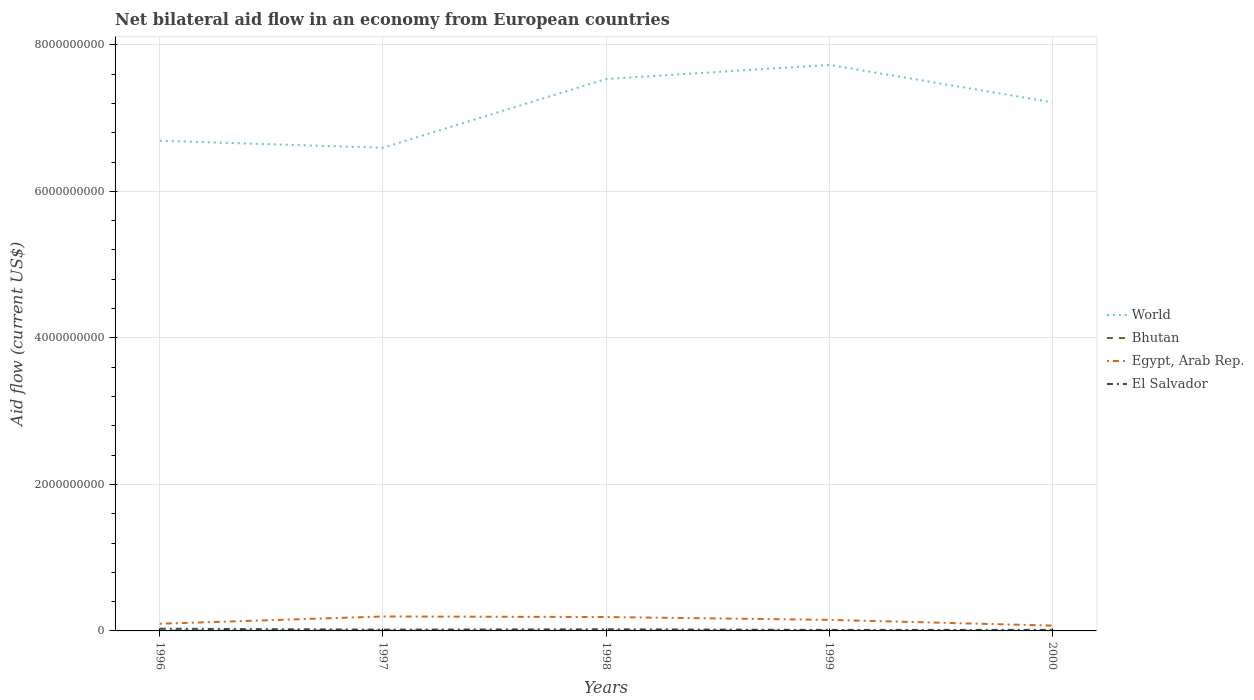What is the total net bilateral aid flow in El Salvador in the graph?
Give a very brief answer. 8.29e+06. What is the difference between the highest and the second highest net bilateral aid flow in Bhutan?
Ensure brevity in your answer.  3.92e+06. Is the net bilateral aid flow in El Salvador strictly greater than the net bilateral aid flow in Egypt, Arab Rep. over the years?
Keep it short and to the point. Yes. How many lines are there?
Your answer should be compact. 4. How many years are there in the graph?
Offer a very short reply. 5. What is the difference between two consecutive major ticks on the Y-axis?
Provide a short and direct response. 2.00e+09. Are the values on the major ticks of Y-axis written in scientific E-notation?
Offer a very short reply. No. Does the graph contain any zero values?
Provide a succinct answer. No. Does the graph contain grids?
Your answer should be compact. Yes. How many legend labels are there?
Provide a short and direct response. 4. How are the legend labels stacked?
Offer a very short reply. Vertical. What is the title of the graph?
Provide a succinct answer. Net bilateral aid flow in an economy from European countries. Does "North America" appear as one of the legend labels in the graph?
Your answer should be very brief. No. What is the label or title of the X-axis?
Offer a very short reply. Years. What is the Aid flow (current US$) in World in 1996?
Provide a short and direct response. 6.69e+09. What is the Aid flow (current US$) in Bhutan in 1996?
Ensure brevity in your answer.  4.82e+06. What is the Aid flow (current US$) of Egypt, Arab Rep. in 1996?
Your answer should be very brief. 9.79e+07. What is the Aid flow (current US$) of El Salvador in 1996?
Make the answer very short. 3.00e+07. What is the Aid flow (current US$) of World in 1997?
Give a very brief answer. 6.60e+09. What is the Aid flow (current US$) in Bhutan in 1997?
Your response must be concise. 3.55e+06. What is the Aid flow (current US$) of Egypt, Arab Rep. in 1997?
Provide a succinct answer. 1.97e+08. What is the Aid flow (current US$) in El Salvador in 1997?
Provide a short and direct response. 1.75e+07. What is the Aid flow (current US$) in World in 1998?
Give a very brief answer. 7.53e+09. What is the Aid flow (current US$) in Bhutan in 1998?
Make the answer very short. 2.79e+06. What is the Aid flow (current US$) of Egypt, Arab Rep. in 1998?
Keep it short and to the point. 1.90e+08. What is the Aid flow (current US$) in El Salvador in 1998?
Offer a very short reply. 2.22e+07. What is the Aid flow (current US$) of World in 1999?
Provide a short and direct response. 7.73e+09. What is the Aid flow (current US$) in Bhutan in 1999?
Your response must be concise. 3.50e+06. What is the Aid flow (current US$) in Egypt, Arab Rep. in 1999?
Make the answer very short. 1.51e+08. What is the Aid flow (current US$) in El Salvador in 1999?
Give a very brief answer. 1.39e+07. What is the Aid flow (current US$) of World in 2000?
Provide a succinct answer. 7.22e+09. What is the Aid flow (current US$) in Egypt, Arab Rep. in 2000?
Keep it short and to the point. 7.25e+07. What is the Aid flow (current US$) in El Salvador in 2000?
Keep it short and to the point. 1.45e+07. Across all years, what is the maximum Aid flow (current US$) in World?
Offer a very short reply. 7.73e+09. Across all years, what is the maximum Aid flow (current US$) in Bhutan?
Offer a very short reply. 4.82e+06. Across all years, what is the maximum Aid flow (current US$) of Egypt, Arab Rep.?
Provide a short and direct response. 1.97e+08. Across all years, what is the maximum Aid flow (current US$) of El Salvador?
Your answer should be very brief. 3.00e+07. Across all years, what is the minimum Aid flow (current US$) of World?
Your answer should be very brief. 6.60e+09. Across all years, what is the minimum Aid flow (current US$) in Bhutan?
Ensure brevity in your answer.  9.00e+05. Across all years, what is the minimum Aid flow (current US$) in Egypt, Arab Rep.?
Your answer should be very brief. 7.25e+07. Across all years, what is the minimum Aid flow (current US$) in El Salvador?
Make the answer very short. 1.39e+07. What is the total Aid flow (current US$) in World in the graph?
Keep it short and to the point. 3.58e+1. What is the total Aid flow (current US$) in Bhutan in the graph?
Offer a terse response. 1.56e+07. What is the total Aid flow (current US$) of Egypt, Arab Rep. in the graph?
Provide a short and direct response. 7.08e+08. What is the total Aid flow (current US$) in El Salvador in the graph?
Your answer should be compact. 9.81e+07. What is the difference between the Aid flow (current US$) of World in 1996 and that in 1997?
Offer a very short reply. 9.51e+07. What is the difference between the Aid flow (current US$) of Bhutan in 1996 and that in 1997?
Provide a short and direct response. 1.27e+06. What is the difference between the Aid flow (current US$) of Egypt, Arab Rep. in 1996 and that in 1997?
Your answer should be compact. -9.91e+07. What is the difference between the Aid flow (current US$) in El Salvador in 1996 and that in 1997?
Keep it short and to the point. 1.25e+07. What is the difference between the Aid flow (current US$) of World in 1996 and that in 1998?
Provide a short and direct response. -8.43e+08. What is the difference between the Aid flow (current US$) in Bhutan in 1996 and that in 1998?
Provide a succinct answer. 2.03e+06. What is the difference between the Aid flow (current US$) in Egypt, Arab Rep. in 1996 and that in 1998?
Provide a short and direct response. -9.19e+07. What is the difference between the Aid flow (current US$) in El Salvador in 1996 and that in 1998?
Ensure brevity in your answer.  7.77e+06. What is the difference between the Aid flow (current US$) of World in 1996 and that in 1999?
Ensure brevity in your answer.  -1.04e+09. What is the difference between the Aid flow (current US$) of Bhutan in 1996 and that in 1999?
Your response must be concise. 1.32e+06. What is the difference between the Aid flow (current US$) in Egypt, Arab Rep. in 1996 and that in 1999?
Make the answer very short. -5.30e+07. What is the difference between the Aid flow (current US$) in El Salvador in 1996 and that in 1999?
Give a very brief answer. 1.61e+07. What is the difference between the Aid flow (current US$) of World in 1996 and that in 2000?
Provide a short and direct response. -5.25e+08. What is the difference between the Aid flow (current US$) of Bhutan in 1996 and that in 2000?
Make the answer very short. 3.92e+06. What is the difference between the Aid flow (current US$) of Egypt, Arab Rep. in 1996 and that in 2000?
Ensure brevity in your answer.  2.54e+07. What is the difference between the Aid flow (current US$) of El Salvador in 1996 and that in 2000?
Make the answer very short. 1.55e+07. What is the difference between the Aid flow (current US$) of World in 1997 and that in 1998?
Your answer should be very brief. -9.38e+08. What is the difference between the Aid flow (current US$) in Bhutan in 1997 and that in 1998?
Your response must be concise. 7.60e+05. What is the difference between the Aid flow (current US$) in Egypt, Arab Rep. in 1997 and that in 1998?
Provide a short and direct response. 7.14e+06. What is the difference between the Aid flow (current US$) in El Salvador in 1997 and that in 1998?
Your answer should be very brief. -4.69e+06. What is the difference between the Aid flow (current US$) in World in 1997 and that in 1999?
Give a very brief answer. -1.13e+09. What is the difference between the Aid flow (current US$) in Egypt, Arab Rep. in 1997 and that in 1999?
Your answer should be compact. 4.61e+07. What is the difference between the Aid flow (current US$) of El Salvador in 1997 and that in 1999?
Provide a succinct answer. 3.60e+06. What is the difference between the Aid flow (current US$) in World in 1997 and that in 2000?
Give a very brief answer. -6.20e+08. What is the difference between the Aid flow (current US$) in Bhutan in 1997 and that in 2000?
Provide a succinct answer. 2.65e+06. What is the difference between the Aid flow (current US$) in Egypt, Arab Rep. in 1997 and that in 2000?
Offer a terse response. 1.24e+08. What is the difference between the Aid flow (current US$) in El Salvador in 1997 and that in 2000?
Keep it short and to the point. 3.03e+06. What is the difference between the Aid flow (current US$) in World in 1998 and that in 1999?
Offer a terse response. -1.93e+08. What is the difference between the Aid flow (current US$) in Bhutan in 1998 and that in 1999?
Provide a succinct answer. -7.10e+05. What is the difference between the Aid flow (current US$) in Egypt, Arab Rep. in 1998 and that in 1999?
Provide a succinct answer. 3.90e+07. What is the difference between the Aid flow (current US$) in El Salvador in 1998 and that in 1999?
Make the answer very short. 8.29e+06. What is the difference between the Aid flow (current US$) of World in 1998 and that in 2000?
Provide a short and direct response. 3.18e+08. What is the difference between the Aid flow (current US$) of Bhutan in 1998 and that in 2000?
Give a very brief answer. 1.89e+06. What is the difference between the Aid flow (current US$) in Egypt, Arab Rep. in 1998 and that in 2000?
Your answer should be compact. 1.17e+08. What is the difference between the Aid flow (current US$) in El Salvador in 1998 and that in 2000?
Give a very brief answer. 7.72e+06. What is the difference between the Aid flow (current US$) of World in 1999 and that in 2000?
Your answer should be compact. 5.11e+08. What is the difference between the Aid flow (current US$) of Bhutan in 1999 and that in 2000?
Your response must be concise. 2.60e+06. What is the difference between the Aid flow (current US$) in Egypt, Arab Rep. in 1999 and that in 2000?
Offer a very short reply. 7.84e+07. What is the difference between the Aid flow (current US$) of El Salvador in 1999 and that in 2000?
Your answer should be very brief. -5.70e+05. What is the difference between the Aid flow (current US$) of World in 1996 and the Aid flow (current US$) of Bhutan in 1997?
Keep it short and to the point. 6.69e+09. What is the difference between the Aid flow (current US$) of World in 1996 and the Aid flow (current US$) of Egypt, Arab Rep. in 1997?
Your response must be concise. 6.49e+09. What is the difference between the Aid flow (current US$) in World in 1996 and the Aid flow (current US$) in El Salvador in 1997?
Provide a short and direct response. 6.67e+09. What is the difference between the Aid flow (current US$) in Bhutan in 1996 and the Aid flow (current US$) in Egypt, Arab Rep. in 1997?
Give a very brief answer. -1.92e+08. What is the difference between the Aid flow (current US$) in Bhutan in 1996 and the Aid flow (current US$) in El Salvador in 1997?
Keep it short and to the point. -1.27e+07. What is the difference between the Aid flow (current US$) of Egypt, Arab Rep. in 1996 and the Aid flow (current US$) of El Salvador in 1997?
Ensure brevity in your answer.  8.04e+07. What is the difference between the Aid flow (current US$) in World in 1996 and the Aid flow (current US$) in Bhutan in 1998?
Make the answer very short. 6.69e+09. What is the difference between the Aid flow (current US$) of World in 1996 and the Aid flow (current US$) of Egypt, Arab Rep. in 1998?
Offer a terse response. 6.50e+09. What is the difference between the Aid flow (current US$) of World in 1996 and the Aid flow (current US$) of El Salvador in 1998?
Give a very brief answer. 6.67e+09. What is the difference between the Aid flow (current US$) of Bhutan in 1996 and the Aid flow (current US$) of Egypt, Arab Rep. in 1998?
Make the answer very short. -1.85e+08. What is the difference between the Aid flow (current US$) of Bhutan in 1996 and the Aid flow (current US$) of El Salvador in 1998?
Offer a very short reply. -1.74e+07. What is the difference between the Aid flow (current US$) of Egypt, Arab Rep. in 1996 and the Aid flow (current US$) of El Salvador in 1998?
Give a very brief answer. 7.57e+07. What is the difference between the Aid flow (current US$) in World in 1996 and the Aid flow (current US$) in Bhutan in 1999?
Your answer should be very brief. 6.69e+09. What is the difference between the Aid flow (current US$) in World in 1996 and the Aid flow (current US$) in Egypt, Arab Rep. in 1999?
Offer a very short reply. 6.54e+09. What is the difference between the Aid flow (current US$) of World in 1996 and the Aid flow (current US$) of El Salvador in 1999?
Provide a succinct answer. 6.68e+09. What is the difference between the Aid flow (current US$) in Bhutan in 1996 and the Aid flow (current US$) in Egypt, Arab Rep. in 1999?
Offer a very short reply. -1.46e+08. What is the difference between the Aid flow (current US$) in Bhutan in 1996 and the Aid flow (current US$) in El Salvador in 1999?
Your response must be concise. -9.10e+06. What is the difference between the Aid flow (current US$) of Egypt, Arab Rep. in 1996 and the Aid flow (current US$) of El Salvador in 1999?
Make the answer very short. 8.40e+07. What is the difference between the Aid flow (current US$) in World in 1996 and the Aid flow (current US$) in Bhutan in 2000?
Give a very brief answer. 6.69e+09. What is the difference between the Aid flow (current US$) in World in 1996 and the Aid flow (current US$) in Egypt, Arab Rep. in 2000?
Ensure brevity in your answer.  6.62e+09. What is the difference between the Aid flow (current US$) in World in 1996 and the Aid flow (current US$) in El Salvador in 2000?
Offer a terse response. 6.68e+09. What is the difference between the Aid flow (current US$) in Bhutan in 1996 and the Aid flow (current US$) in Egypt, Arab Rep. in 2000?
Offer a terse response. -6.77e+07. What is the difference between the Aid flow (current US$) of Bhutan in 1996 and the Aid flow (current US$) of El Salvador in 2000?
Your answer should be compact. -9.67e+06. What is the difference between the Aid flow (current US$) in Egypt, Arab Rep. in 1996 and the Aid flow (current US$) in El Salvador in 2000?
Provide a succinct answer. 8.34e+07. What is the difference between the Aid flow (current US$) in World in 1997 and the Aid flow (current US$) in Bhutan in 1998?
Offer a very short reply. 6.59e+09. What is the difference between the Aid flow (current US$) in World in 1997 and the Aid flow (current US$) in Egypt, Arab Rep. in 1998?
Offer a very short reply. 6.41e+09. What is the difference between the Aid flow (current US$) of World in 1997 and the Aid flow (current US$) of El Salvador in 1998?
Offer a terse response. 6.57e+09. What is the difference between the Aid flow (current US$) of Bhutan in 1997 and the Aid flow (current US$) of Egypt, Arab Rep. in 1998?
Your answer should be very brief. -1.86e+08. What is the difference between the Aid flow (current US$) in Bhutan in 1997 and the Aid flow (current US$) in El Salvador in 1998?
Offer a very short reply. -1.87e+07. What is the difference between the Aid flow (current US$) in Egypt, Arab Rep. in 1997 and the Aid flow (current US$) in El Salvador in 1998?
Provide a succinct answer. 1.75e+08. What is the difference between the Aid flow (current US$) of World in 1997 and the Aid flow (current US$) of Bhutan in 1999?
Offer a terse response. 6.59e+09. What is the difference between the Aid flow (current US$) of World in 1997 and the Aid flow (current US$) of Egypt, Arab Rep. in 1999?
Ensure brevity in your answer.  6.44e+09. What is the difference between the Aid flow (current US$) in World in 1997 and the Aid flow (current US$) in El Salvador in 1999?
Ensure brevity in your answer.  6.58e+09. What is the difference between the Aid flow (current US$) in Bhutan in 1997 and the Aid flow (current US$) in Egypt, Arab Rep. in 1999?
Give a very brief answer. -1.47e+08. What is the difference between the Aid flow (current US$) of Bhutan in 1997 and the Aid flow (current US$) of El Salvador in 1999?
Keep it short and to the point. -1.04e+07. What is the difference between the Aid flow (current US$) of Egypt, Arab Rep. in 1997 and the Aid flow (current US$) of El Salvador in 1999?
Provide a short and direct response. 1.83e+08. What is the difference between the Aid flow (current US$) in World in 1997 and the Aid flow (current US$) in Bhutan in 2000?
Your response must be concise. 6.59e+09. What is the difference between the Aid flow (current US$) of World in 1997 and the Aid flow (current US$) of Egypt, Arab Rep. in 2000?
Give a very brief answer. 6.52e+09. What is the difference between the Aid flow (current US$) in World in 1997 and the Aid flow (current US$) in El Salvador in 2000?
Give a very brief answer. 6.58e+09. What is the difference between the Aid flow (current US$) in Bhutan in 1997 and the Aid flow (current US$) in Egypt, Arab Rep. in 2000?
Give a very brief answer. -6.90e+07. What is the difference between the Aid flow (current US$) of Bhutan in 1997 and the Aid flow (current US$) of El Salvador in 2000?
Your response must be concise. -1.09e+07. What is the difference between the Aid flow (current US$) in Egypt, Arab Rep. in 1997 and the Aid flow (current US$) in El Salvador in 2000?
Your answer should be very brief. 1.82e+08. What is the difference between the Aid flow (current US$) of World in 1998 and the Aid flow (current US$) of Bhutan in 1999?
Give a very brief answer. 7.53e+09. What is the difference between the Aid flow (current US$) of World in 1998 and the Aid flow (current US$) of Egypt, Arab Rep. in 1999?
Ensure brevity in your answer.  7.38e+09. What is the difference between the Aid flow (current US$) of World in 1998 and the Aid flow (current US$) of El Salvador in 1999?
Offer a terse response. 7.52e+09. What is the difference between the Aid flow (current US$) in Bhutan in 1998 and the Aid flow (current US$) in Egypt, Arab Rep. in 1999?
Your answer should be very brief. -1.48e+08. What is the difference between the Aid flow (current US$) of Bhutan in 1998 and the Aid flow (current US$) of El Salvador in 1999?
Your answer should be very brief. -1.11e+07. What is the difference between the Aid flow (current US$) of Egypt, Arab Rep. in 1998 and the Aid flow (current US$) of El Salvador in 1999?
Your answer should be very brief. 1.76e+08. What is the difference between the Aid flow (current US$) of World in 1998 and the Aid flow (current US$) of Bhutan in 2000?
Offer a terse response. 7.53e+09. What is the difference between the Aid flow (current US$) of World in 1998 and the Aid flow (current US$) of Egypt, Arab Rep. in 2000?
Provide a short and direct response. 7.46e+09. What is the difference between the Aid flow (current US$) in World in 1998 and the Aid flow (current US$) in El Salvador in 2000?
Offer a terse response. 7.52e+09. What is the difference between the Aid flow (current US$) in Bhutan in 1998 and the Aid flow (current US$) in Egypt, Arab Rep. in 2000?
Provide a succinct answer. -6.97e+07. What is the difference between the Aid flow (current US$) in Bhutan in 1998 and the Aid flow (current US$) in El Salvador in 2000?
Your response must be concise. -1.17e+07. What is the difference between the Aid flow (current US$) of Egypt, Arab Rep. in 1998 and the Aid flow (current US$) of El Salvador in 2000?
Provide a short and direct response. 1.75e+08. What is the difference between the Aid flow (current US$) of World in 1999 and the Aid flow (current US$) of Bhutan in 2000?
Your response must be concise. 7.73e+09. What is the difference between the Aid flow (current US$) of World in 1999 and the Aid flow (current US$) of Egypt, Arab Rep. in 2000?
Keep it short and to the point. 7.65e+09. What is the difference between the Aid flow (current US$) in World in 1999 and the Aid flow (current US$) in El Salvador in 2000?
Your response must be concise. 7.71e+09. What is the difference between the Aid flow (current US$) in Bhutan in 1999 and the Aid flow (current US$) in Egypt, Arab Rep. in 2000?
Offer a very short reply. -6.90e+07. What is the difference between the Aid flow (current US$) of Bhutan in 1999 and the Aid flow (current US$) of El Salvador in 2000?
Keep it short and to the point. -1.10e+07. What is the difference between the Aid flow (current US$) of Egypt, Arab Rep. in 1999 and the Aid flow (current US$) of El Salvador in 2000?
Provide a short and direct response. 1.36e+08. What is the average Aid flow (current US$) of World per year?
Your response must be concise. 7.15e+09. What is the average Aid flow (current US$) of Bhutan per year?
Give a very brief answer. 3.11e+06. What is the average Aid flow (current US$) of Egypt, Arab Rep. per year?
Give a very brief answer. 1.42e+08. What is the average Aid flow (current US$) in El Salvador per year?
Provide a succinct answer. 1.96e+07. In the year 1996, what is the difference between the Aid flow (current US$) of World and Aid flow (current US$) of Bhutan?
Your answer should be very brief. 6.69e+09. In the year 1996, what is the difference between the Aid flow (current US$) in World and Aid flow (current US$) in Egypt, Arab Rep.?
Provide a short and direct response. 6.59e+09. In the year 1996, what is the difference between the Aid flow (current US$) in World and Aid flow (current US$) in El Salvador?
Make the answer very short. 6.66e+09. In the year 1996, what is the difference between the Aid flow (current US$) of Bhutan and Aid flow (current US$) of Egypt, Arab Rep.?
Your answer should be compact. -9.31e+07. In the year 1996, what is the difference between the Aid flow (current US$) in Bhutan and Aid flow (current US$) in El Salvador?
Your answer should be very brief. -2.52e+07. In the year 1996, what is the difference between the Aid flow (current US$) in Egypt, Arab Rep. and Aid flow (current US$) in El Salvador?
Your answer should be compact. 6.79e+07. In the year 1997, what is the difference between the Aid flow (current US$) in World and Aid flow (current US$) in Bhutan?
Your answer should be very brief. 6.59e+09. In the year 1997, what is the difference between the Aid flow (current US$) in World and Aid flow (current US$) in Egypt, Arab Rep.?
Provide a short and direct response. 6.40e+09. In the year 1997, what is the difference between the Aid flow (current US$) in World and Aid flow (current US$) in El Salvador?
Offer a very short reply. 6.58e+09. In the year 1997, what is the difference between the Aid flow (current US$) of Bhutan and Aid flow (current US$) of Egypt, Arab Rep.?
Provide a short and direct response. -1.93e+08. In the year 1997, what is the difference between the Aid flow (current US$) of Bhutan and Aid flow (current US$) of El Salvador?
Provide a succinct answer. -1.40e+07. In the year 1997, what is the difference between the Aid flow (current US$) in Egypt, Arab Rep. and Aid flow (current US$) in El Salvador?
Give a very brief answer. 1.79e+08. In the year 1998, what is the difference between the Aid flow (current US$) in World and Aid flow (current US$) in Bhutan?
Provide a succinct answer. 7.53e+09. In the year 1998, what is the difference between the Aid flow (current US$) in World and Aid flow (current US$) in Egypt, Arab Rep.?
Your answer should be compact. 7.34e+09. In the year 1998, what is the difference between the Aid flow (current US$) of World and Aid flow (current US$) of El Salvador?
Provide a short and direct response. 7.51e+09. In the year 1998, what is the difference between the Aid flow (current US$) of Bhutan and Aid flow (current US$) of Egypt, Arab Rep.?
Your response must be concise. -1.87e+08. In the year 1998, what is the difference between the Aid flow (current US$) of Bhutan and Aid flow (current US$) of El Salvador?
Ensure brevity in your answer.  -1.94e+07. In the year 1998, what is the difference between the Aid flow (current US$) of Egypt, Arab Rep. and Aid flow (current US$) of El Salvador?
Ensure brevity in your answer.  1.68e+08. In the year 1999, what is the difference between the Aid flow (current US$) in World and Aid flow (current US$) in Bhutan?
Provide a succinct answer. 7.72e+09. In the year 1999, what is the difference between the Aid flow (current US$) in World and Aid flow (current US$) in Egypt, Arab Rep.?
Provide a short and direct response. 7.58e+09. In the year 1999, what is the difference between the Aid flow (current US$) of World and Aid flow (current US$) of El Salvador?
Make the answer very short. 7.71e+09. In the year 1999, what is the difference between the Aid flow (current US$) of Bhutan and Aid flow (current US$) of Egypt, Arab Rep.?
Your response must be concise. -1.47e+08. In the year 1999, what is the difference between the Aid flow (current US$) of Bhutan and Aid flow (current US$) of El Salvador?
Your response must be concise. -1.04e+07. In the year 1999, what is the difference between the Aid flow (current US$) in Egypt, Arab Rep. and Aid flow (current US$) in El Salvador?
Your answer should be very brief. 1.37e+08. In the year 2000, what is the difference between the Aid flow (current US$) in World and Aid flow (current US$) in Bhutan?
Your response must be concise. 7.21e+09. In the year 2000, what is the difference between the Aid flow (current US$) in World and Aid flow (current US$) in Egypt, Arab Rep.?
Your response must be concise. 7.14e+09. In the year 2000, what is the difference between the Aid flow (current US$) of World and Aid flow (current US$) of El Salvador?
Provide a succinct answer. 7.20e+09. In the year 2000, what is the difference between the Aid flow (current US$) in Bhutan and Aid flow (current US$) in Egypt, Arab Rep.?
Make the answer very short. -7.16e+07. In the year 2000, what is the difference between the Aid flow (current US$) of Bhutan and Aid flow (current US$) of El Salvador?
Your answer should be very brief. -1.36e+07. In the year 2000, what is the difference between the Aid flow (current US$) of Egypt, Arab Rep. and Aid flow (current US$) of El Salvador?
Ensure brevity in your answer.  5.80e+07. What is the ratio of the Aid flow (current US$) of World in 1996 to that in 1997?
Your response must be concise. 1.01. What is the ratio of the Aid flow (current US$) of Bhutan in 1996 to that in 1997?
Your answer should be compact. 1.36. What is the ratio of the Aid flow (current US$) of Egypt, Arab Rep. in 1996 to that in 1997?
Provide a short and direct response. 0.5. What is the ratio of the Aid flow (current US$) in El Salvador in 1996 to that in 1997?
Your response must be concise. 1.71. What is the ratio of the Aid flow (current US$) of World in 1996 to that in 1998?
Your answer should be compact. 0.89. What is the ratio of the Aid flow (current US$) in Bhutan in 1996 to that in 1998?
Offer a terse response. 1.73. What is the ratio of the Aid flow (current US$) in Egypt, Arab Rep. in 1996 to that in 1998?
Provide a succinct answer. 0.52. What is the ratio of the Aid flow (current US$) in El Salvador in 1996 to that in 1998?
Your answer should be very brief. 1.35. What is the ratio of the Aid flow (current US$) of World in 1996 to that in 1999?
Your answer should be compact. 0.87. What is the ratio of the Aid flow (current US$) of Bhutan in 1996 to that in 1999?
Your answer should be very brief. 1.38. What is the ratio of the Aid flow (current US$) of Egypt, Arab Rep. in 1996 to that in 1999?
Provide a succinct answer. 0.65. What is the ratio of the Aid flow (current US$) in El Salvador in 1996 to that in 1999?
Keep it short and to the point. 2.15. What is the ratio of the Aid flow (current US$) in World in 1996 to that in 2000?
Provide a succinct answer. 0.93. What is the ratio of the Aid flow (current US$) in Bhutan in 1996 to that in 2000?
Offer a terse response. 5.36. What is the ratio of the Aid flow (current US$) of Egypt, Arab Rep. in 1996 to that in 2000?
Keep it short and to the point. 1.35. What is the ratio of the Aid flow (current US$) in El Salvador in 1996 to that in 2000?
Keep it short and to the point. 2.07. What is the ratio of the Aid flow (current US$) of World in 1997 to that in 1998?
Ensure brevity in your answer.  0.88. What is the ratio of the Aid flow (current US$) in Bhutan in 1997 to that in 1998?
Ensure brevity in your answer.  1.27. What is the ratio of the Aid flow (current US$) of Egypt, Arab Rep. in 1997 to that in 1998?
Provide a short and direct response. 1.04. What is the ratio of the Aid flow (current US$) of El Salvador in 1997 to that in 1998?
Offer a terse response. 0.79. What is the ratio of the Aid flow (current US$) of World in 1997 to that in 1999?
Your answer should be compact. 0.85. What is the ratio of the Aid flow (current US$) in Bhutan in 1997 to that in 1999?
Offer a terse response. 1.01. What is the ratio of the Aid flow (current US$) of Egypt, Arab Rep. in 1997 to that in 1999?
Offer a terse response. 1.31. What is the ratio of the Aid flow (current US$) in El Salvador in 1997 to that in 1999?
Ensure brevity in your answer.  1.26. What is the ratio of the Aid flow (current US$) in World in 1997 to that in 2000?
Ensure brevity in your answer.  0.91. What is the ratio of the Aid flow (current US$) of Bhutan in 1997 to that in 2000?
Ensure brevity in your answer.  3.94. What is the ratio of the Aid flow (current US$) in Egypt, Arab Rep. in 1997 to that in 2000?
Provide a succinct answer. 2.72. What is the ratio of the Aid flow (current US$) in El Salvador in 1997 to that in 2000?
Give a very brief answer. 1.21. What is the ratio of the Aid flow (current US$) in Bhutan in 1998 to that in 1999?
Give a very brief answer. 0.8. What is the ratio of the Aid flow (current US$) of Egypt, Arab Rep. in 1998 to that in 1999?
Offer a very short reply. 1.26. What is the ratio of the Aid flow (current US$) in El Salvador in 1998 to that in 1999?
Offer a terse response. 1.6. What is the ratio of the Aid flow (current US$) in World in 1998 to that in 2000?
Ensure brevity in your answer.  1.04. What is the ratio of the Aid flow (current US$) in Egypt, Arab Rep. in 1998 to that in 2000?
Give a very brief answer. 2.62. What is the ratio of the Aid flow (current US$) in El Salvador in 1998 to that in 2000?
Keep it short and to the point. 1.53. What is the ratio of the Aid flow (current US$) of World in 1999 to that in 2000?
Your response must be concise. 1.07. What is the ratio of the Aid flow (current US$) of Bhutan in 1999 to that in 2000?
Provide a short and direct response. 3.89. What is the ratio of the Aid flow (current US$) in Egypt, Arab Rep. in 1999 to that in 2000?
Ensure brevity in your answer.  2.08. What is the ratio of the Aid flow (current US$) of El Salvador in 1999 to that in 2000?
Keep it short and to the point. 0.96. What is the difference between the highest and the second highest Aid flow (current US$) in World?
Offer a very short reply. 1.93e+08. What is the difference between the highest and the second highest Aid flow (current US$) in Bhutan?
Offer a very short reply. 1.27e+06. What is the difference between the highest and the second highest Aid flow (current US$) in Egypt, Arab Rep.?
Ensure brevity in your answer.  7.14e+06. What is the difference between the highest and the second highest Aid flow (current US$) of El Salvador?
Provide a short and direct response. 7.77e+06. What is the difference between the highest and the lowest Aid flow (current US$) of World?
Provide a short and direct response. 1.13e+09. What is the difference between the highest and the lowest Aid flow (current US$) in Bhutan?
Keep it short and to the point. 3.92e+06. What is the difference between the highest and the lowest Aid flow (current US$) in Egypt, Arab Rep.?
Your response must be concise. 1.24e+08. What is the difference between the highest and the lowest Aid flow (current US$) in El Salvador?
Offer a terse response. 1.61e+07. 